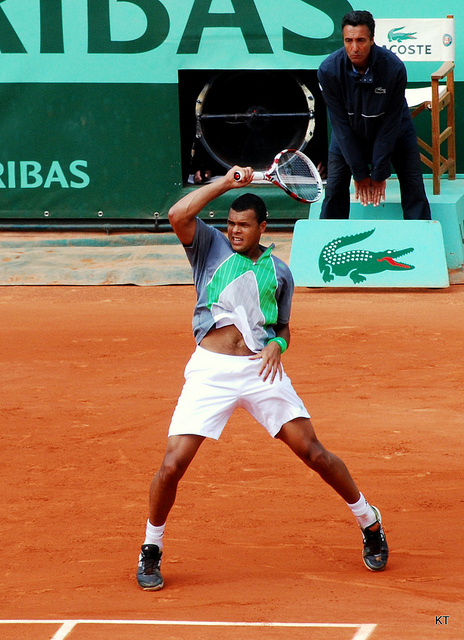Can you tell me more about the player's position and technique? Certainly. The player is caught in a typical backhand stance, with his left foot forward, which suggests that he is right-handed. His knees are bent to maintain balance and to allow for quick movement after the shot. The racket is being swung with both hands for added power and control. This technique indicates that he's likely hitting a two-handed backhand, a common shot in modern tennis. 